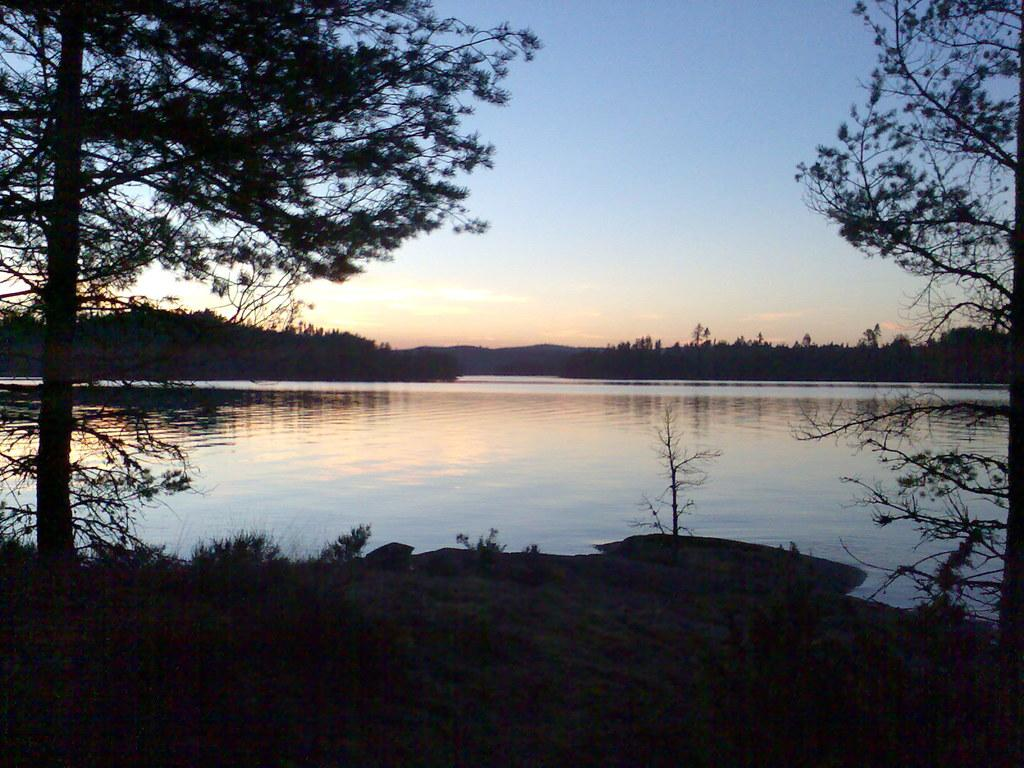What is the main feature of the dark area in the image? The main features of the dark area are grass, trees, water, and the sky visible in the background. Can you describe the vegetation in the dark area? There is grass and trees in the dark area. What can be seen in the water in the dark area? The facts provided do not specify any details about the water in the dark area. What is visible in the background of the dark area? The sky is visible in the background of the dark area. What type of string is used to tie the trucks together in the image? There are no trucks present in the image, so there is no string used to tie them together. 